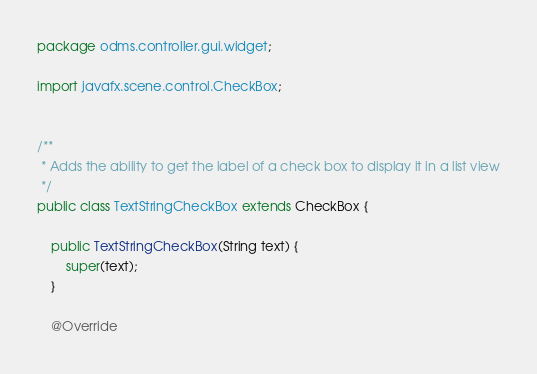Convert code to text. <code><loc_0><loc_0><loc_500><loc_500><_Java_>package odms.controller.gui.widget;

import javafx.scene.control.CheckBox;


/**
 * Adds the ability to get the label of a check box to display it in a list view
 */
public class TextStringCheckBox extends CheckBox {

    public TextStringCheckBox(String text) {
        super(text);
    }

    @Override</code> 